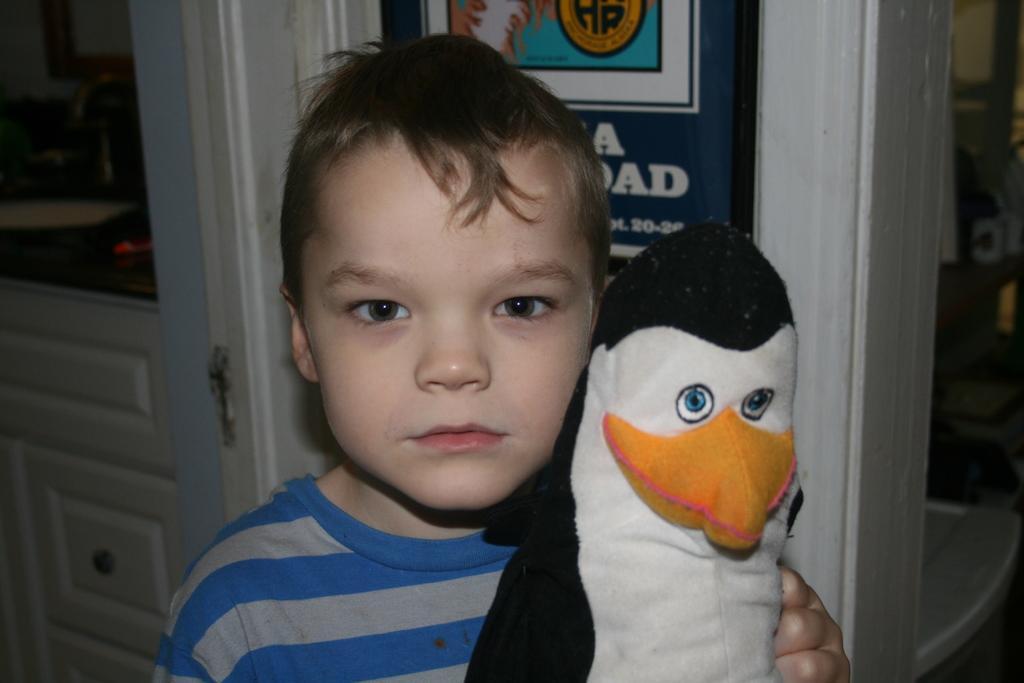Please provide a concise description of this image. In the center of the image we can see a boy is wearing t-shirt and holding a doll. In the background of the image we can see the wall, doors, board, cupboards and some other objects. In the top left corner we can see a sink, tap, wall, board. In the bottom right corner we can see the floor. 